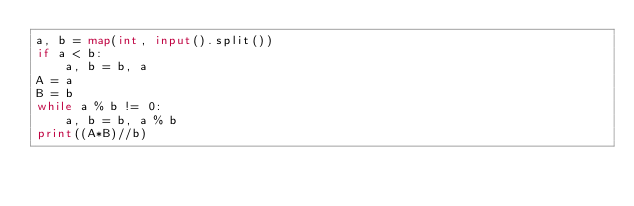Convert code to text. <code><loc_0><loc_0><loc_500><loc_500><_Python_>a, b = map(int, input().split())
if a < b:
    a, b = b, a
A = a
B = b
while a % b != 0:
    a, b = b, a % b
print((A*B)//b)
</code> 